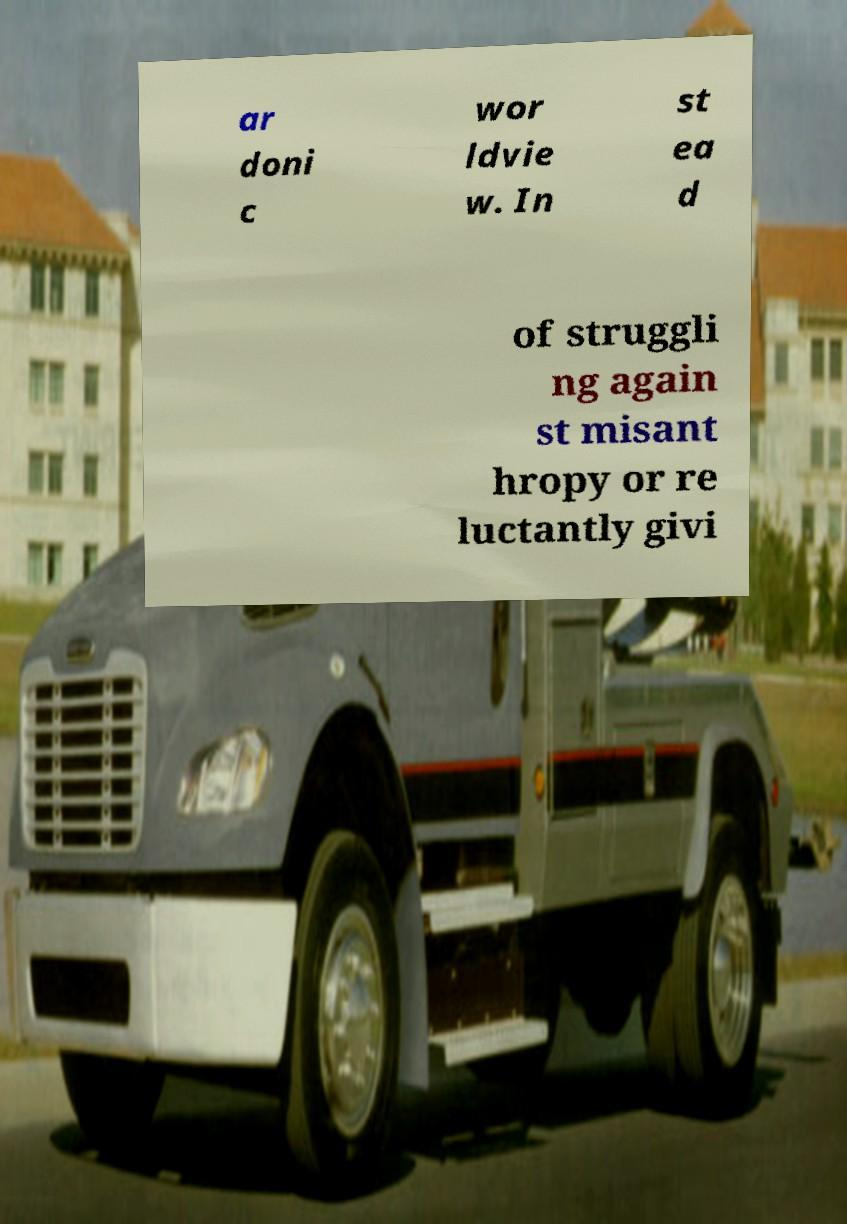I need the written content from this picture converted into text. Can you do that? ar doni c wor ldvie w. In st ea d of struggli ng again st misant hropy or re luctantly givi 